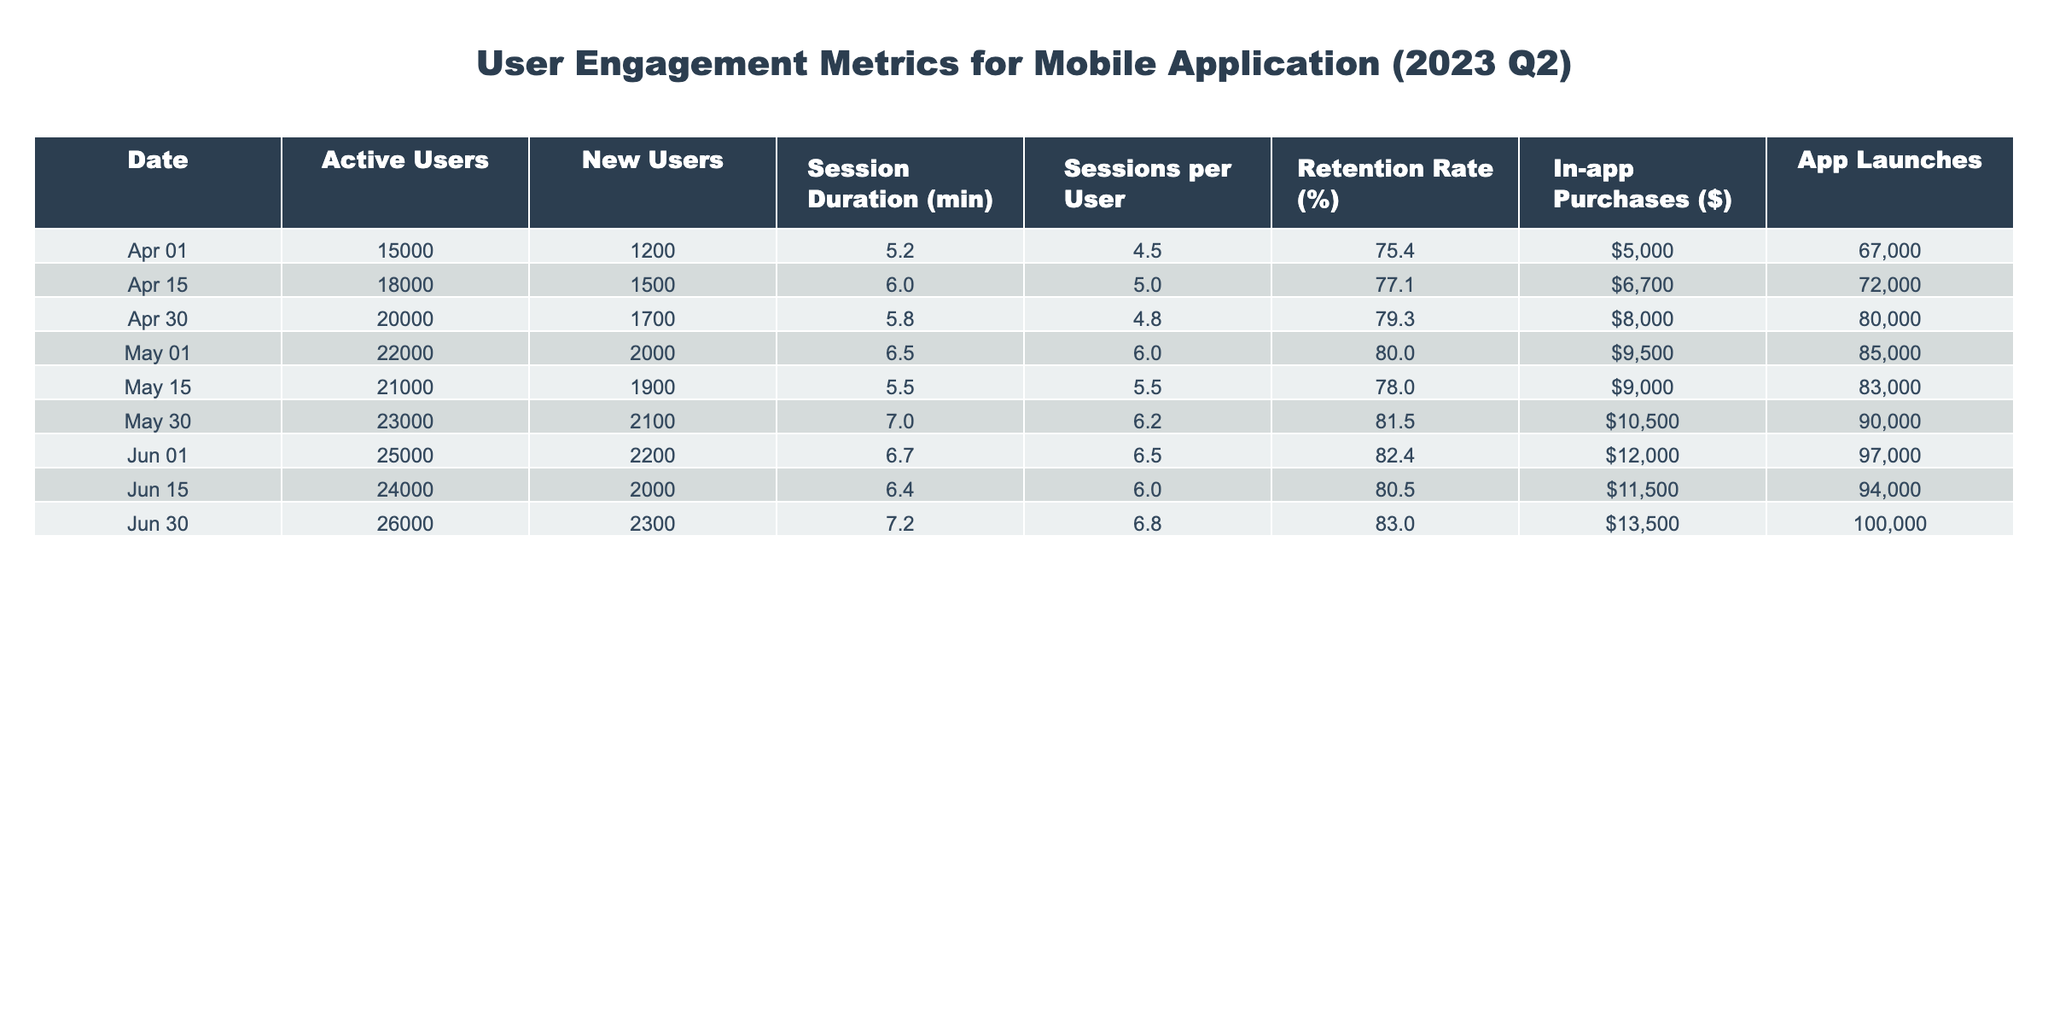What's the retention rate on June 1, 2023? The retention rate is found in the column for "Retention Rate (%)" corresponding to the date "2023-06-01". According to the table, the value is 82.4.
Answer: 82.4 What was the total number of in-app purchases made in April 2023? To find the total number of in-app purchases for April, we add the values from "In-app Purchases ($)" for the dates within April: 5000 + 6700 + 8000 = 19700.
Answer: 19700 Did the active users increase from April 30 to May 15, 2023? We check the active users on April 30 (20000) and May 15 (21000). Since 21000 is greater than 20000, there was an increase.
Answer: Yes What is the average session duration across all dates in June 2023? To calculate the average session duration, we sum the session duration for June: 6.4 + 6.7 + 7.2 = 20.3 and divide by the number of entries (3) to get 20.3/3 = 6.77.
Answer: 6.77 What was the highest number of new users in a single day during Q2 2023? We look through the "New Users" column and find that the maximum value is 2300, which occurred on June 30, 2023.
Answer: 2300 What was the session duration on the days with the lowest retention rate? The lowest retention rate in the table is 75.4%, which corresponds to April 1, 2023. The session duration for that day is 5.2 minutes.
Answer: 5.2 How many app launches occurred in May 2023 altogether? We total the "App Launches" values for May: 85000 + 83000 = 168000 for the days in May, which gives us the total number of launches for that month.
Answer: 168000 Which day had the largest increase in active users compared to the previous date? Comparing active users day by day: April 15 (18000) to April 1 (15000) shows an increase of 3000; from April 30 (20000) to May 1 (22000) shows an increase of 2000. The largest increase was from April 1 to April 15.
Answer: April 15 Was there an increase in the average sessions per user from May 30 to June 30? The average sessions per user for May 30 is 6.2 and for June 30 is 6.8. Since 6.8 is greater than 6.2, there was an increase.
Answer: Yes 